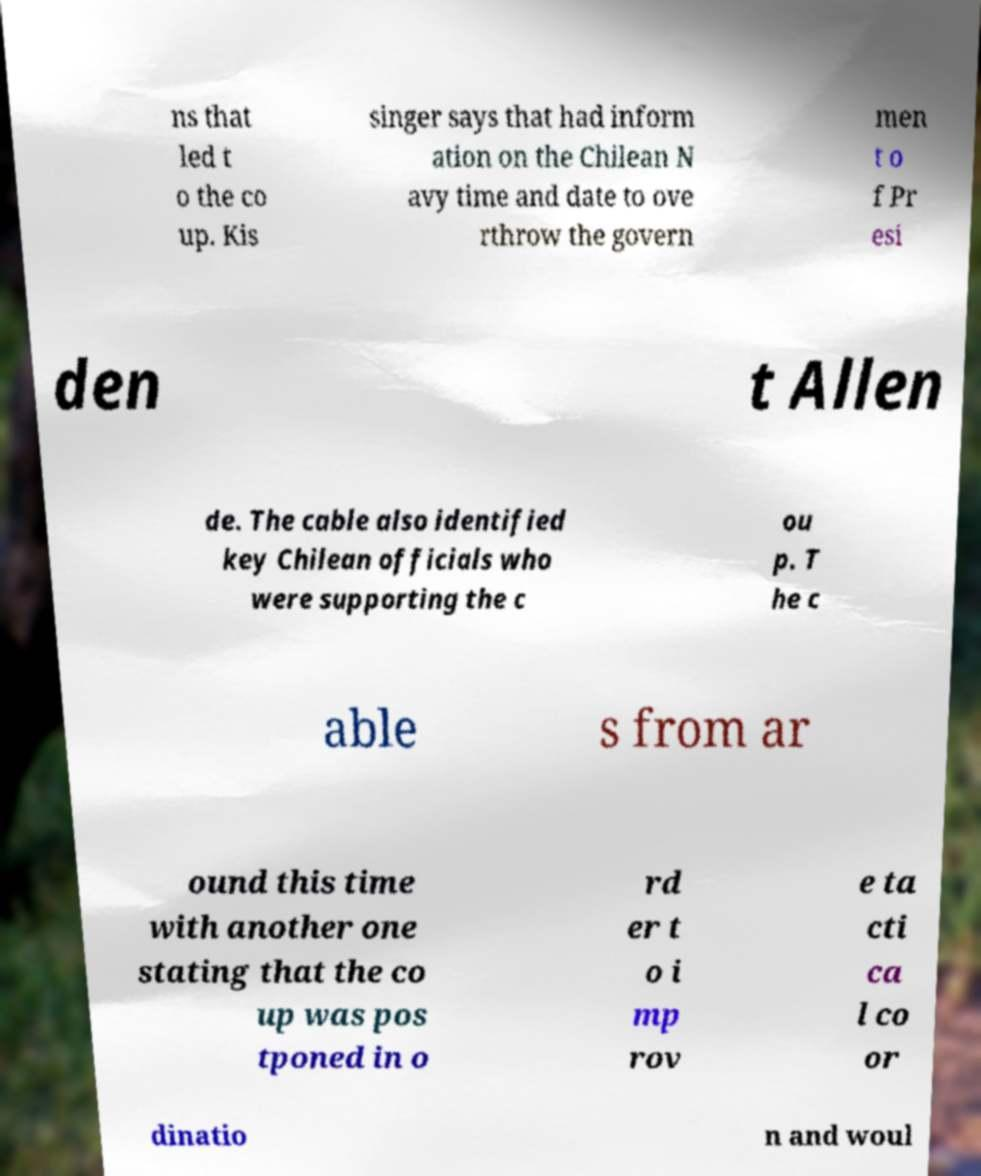Could you assist in decoding the text presented in this image and type it out clearly? ns that led t o the co up. Kis singer says that had inform ation on the Chilean N avy time and date to ove rthrow the govern men t o f Pr esi den t Allen de. The cable also identified key Chilean officials who were supporting the c ou p. T he c able s from ar ound this time with another one stating that the co up was pos tponed in o rd er t o i mp rov e ta cti ca l co or dinatio n and woul 